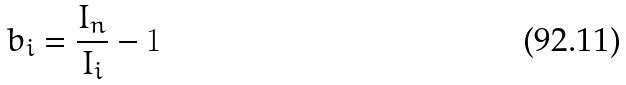<formula> <loc_0><loc_0><loc_500><loc_500>b _ { i } = \frac { I _ { n } } { I _ { i } } - 1</formula> 